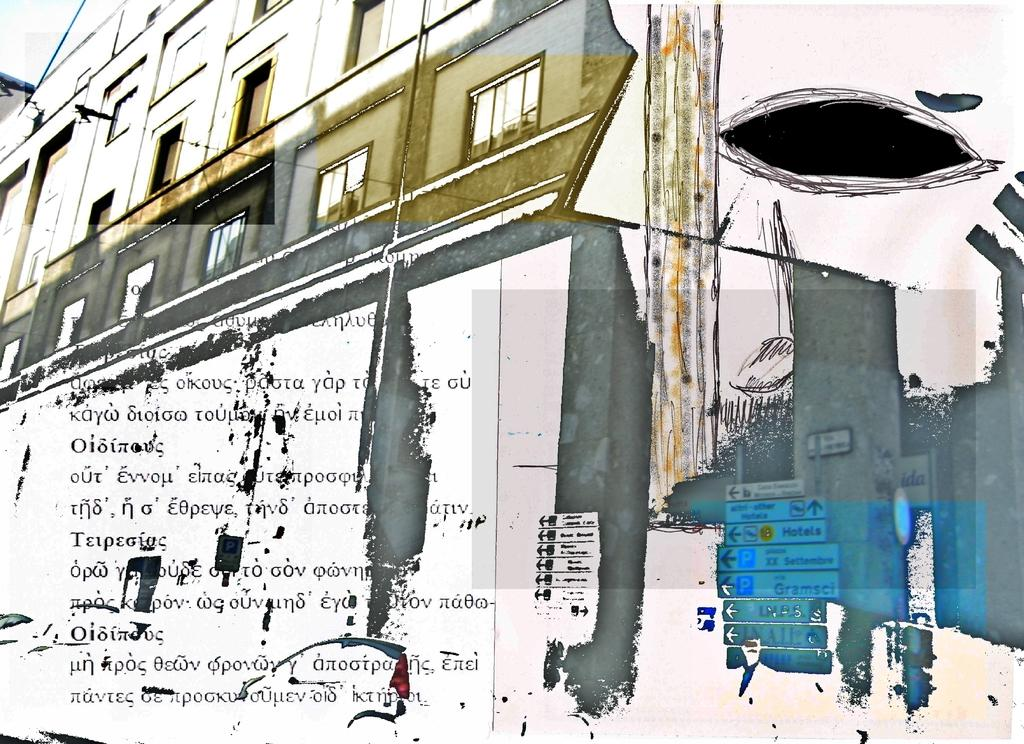What is the main structure visible in the image? There is a building in the image. Is there any text or writing associated with the building? Yes, there is text or writing below the building. What else can be seen in the image besides the building and text? There are other objects in the right corner of the image. How does the honey flow around the building in the image? There is no honey present in the image, so it cannot flow around the building. 